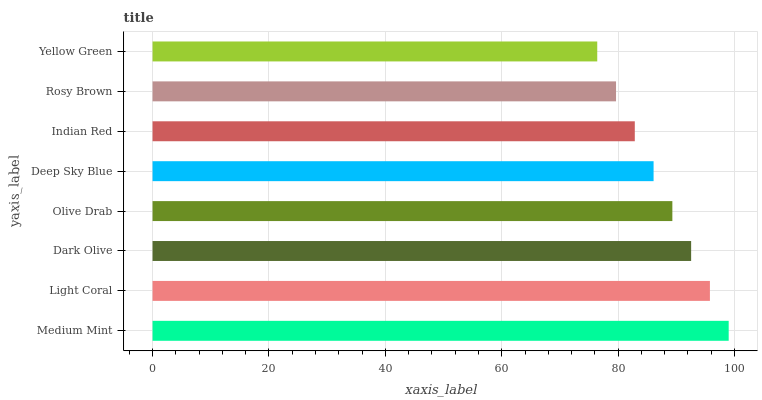Is Yellow Green the minimum?
Answer yes or no. Yes. Is Medium Mint the maximum?
Answer yes or no. Yes. Is Light Coral the minimum?
Answer yes or no. No. Is Light Coral the maximum?
Answer yes or no. No. Is Medium Mint greater than Light Coral?
Answer yes or no. Yes. Is Light Coral less than Medium Mint?
Answer yes or no. Yes. Is Light Coral greater than Medium Mint?
Answer yes or no. No. Is Medium Mint less than Light Coral?
Answer yes or no. No. Is Olive Drab the high median?
Answer yes or no. Yes. Is Deep Sky Blue the low median?
Answer yes or no. Yes. Is Medium Mint the high median?
Answer yes or no. No. Is Yellow Green the low median?
Answer yes or no. No. 